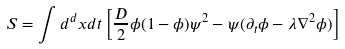<formula> <loc_0><loc_0><loc_500><loc_500>S = \int d ^ { d } x d t \left [ \frac { D } { 2 } \phi ( 1 - \phi ) \psi ^ { 2 } - \psi ( \partial _ { t } \phi - \lambda \nabla ^ { 2 } \phi ) \right ]</formula> 